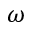<formula> <loc_0><loc_0><loc_500><loc_500>\omega</formula> 